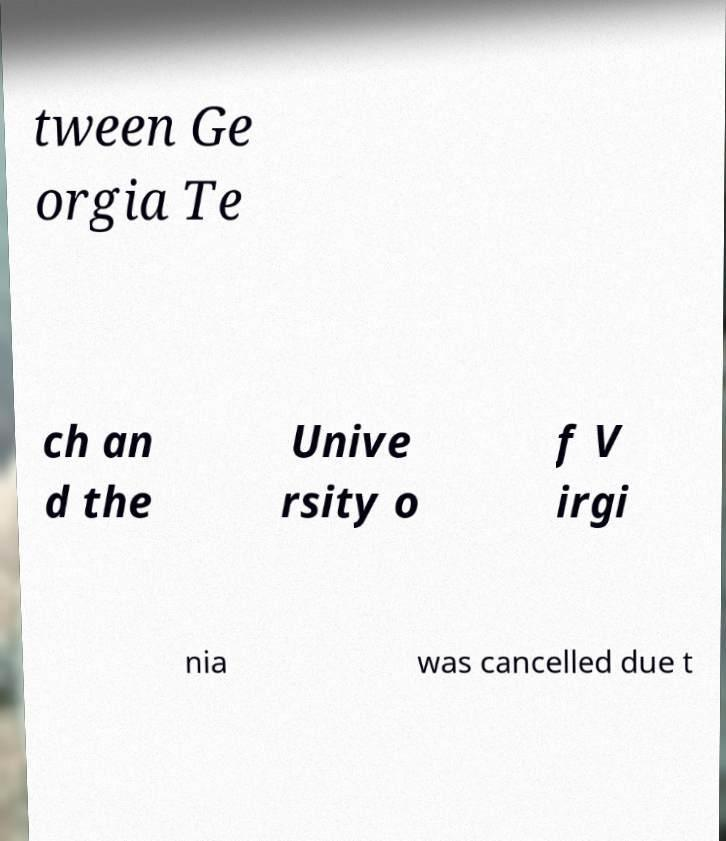Could you assist in decoding the text presented in this image and type it out clearly? tween Ge orgia Te ch an d the Unive rsity o f V irgi nia was cancelled due t 